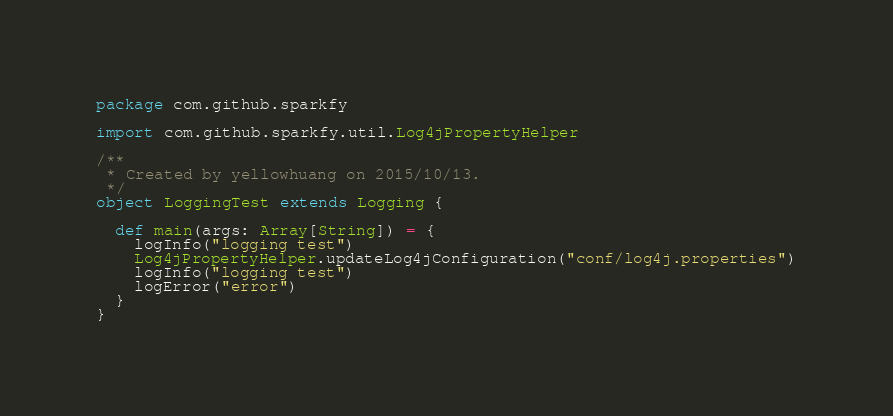<code> <loc_0><loc_0><loc_500><loc_500><_Scala_>package com.github.sparkfy

import com.github.sparkfy.util.Log4jPropertyHelper

/**
 * Created by yellowhuang on 2015/10/13.
 */
object LoggingTest extends Logging {

  def main(args: Array[String]) = {
    logInfo("logging test")
    Log4jPropertyHelper.updateLog4jConfiguration("conf/log4j.properties")
    logInfo("logging test")
    logError("error")
  }
}
</code> 